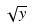Convert formula to latex. <formula><loc_0><loc_0><loc_500><loc_500>\sqrt { y }</formula> 